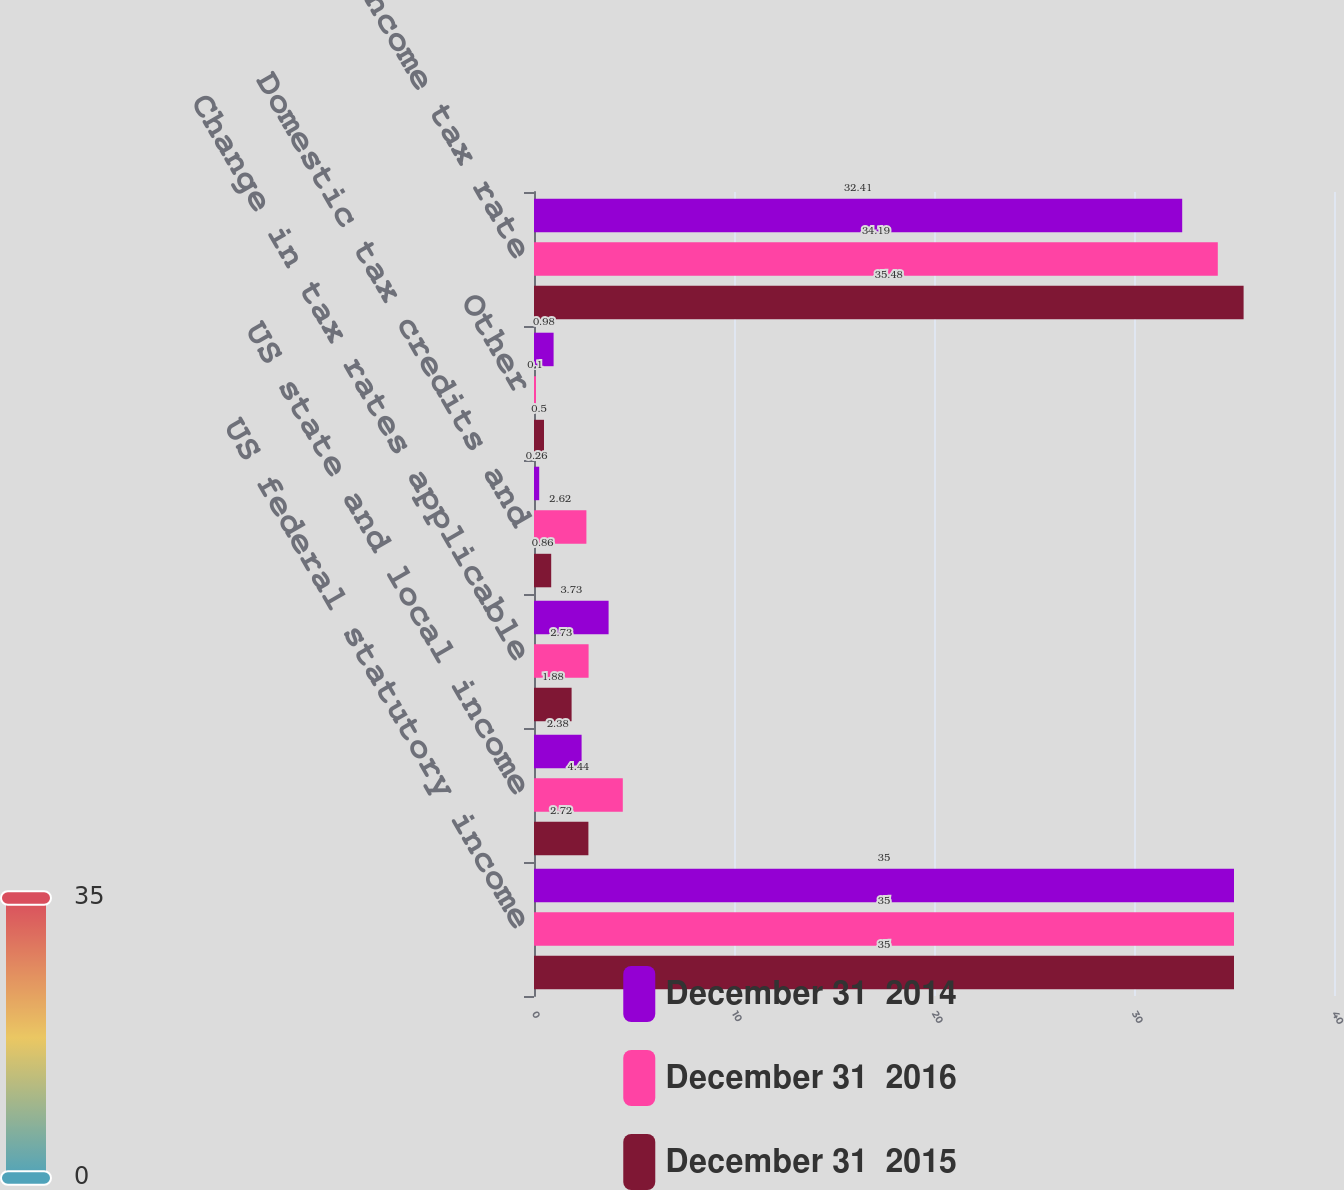Convert chart. <chart><loc_0><loc_0><loc_500><loc_500><stacked_bar_chart><ecel><fcel>US federal statutory income<fcel>US state and local income<fcel>Change in tax rates applicable<fcel>Domestic tax credits and<fcel>Other<fcel>Effective income tax rate<nl><fcel>December 31  2014<fcel>35<fcel>2.38<fcel>3.73<fcel>0.26<fcel>0.98<fcel>32.41<nl><fcel>December 31  2016<fcel>35<fcel>4.44<fcel>2.73<fcel>2.62<fcel>0.1<fcel>34.19<nl><fcel>December 31  2015<fcel>35<fcel>2.72<fcel>1.88<fcel>0.86<fcel>0.5<fcel>35.48<nl></chart> 